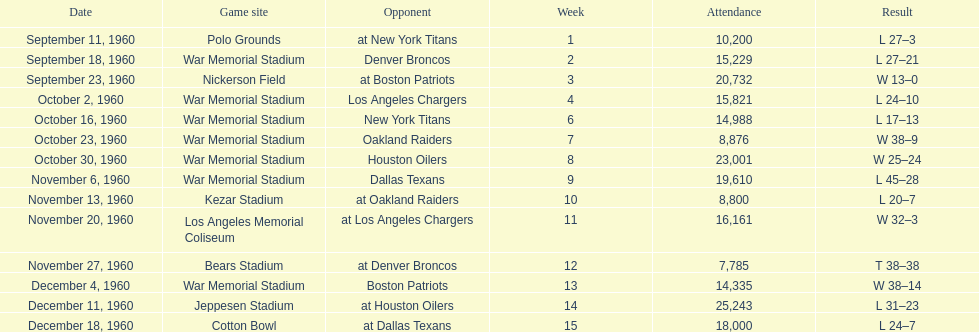What were the total number of games played in november? 4. 